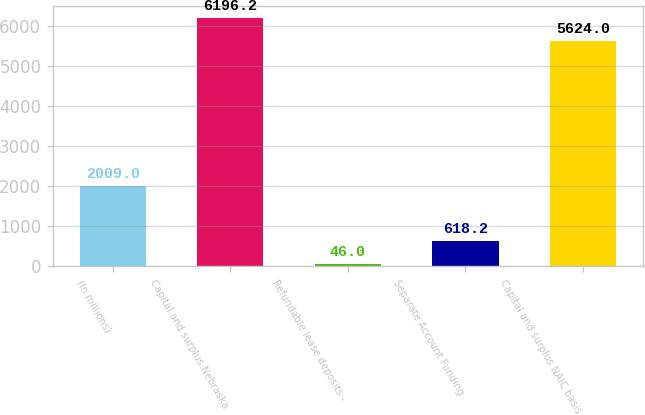<chart> <loc_0><loc_0><loc_500><loc_500><bar_chart><fcel>(In millions)<fcel>Capital and surplus Nebraska<fcel>Refundable lease deposits -<fcel>Separate Account Funding<fcel>Capital and surplus NAIC basis<nl><fcel>2009<fcel>6196.2<fcel>46<fcel>618.2<fcel>5624<nl></chart> 